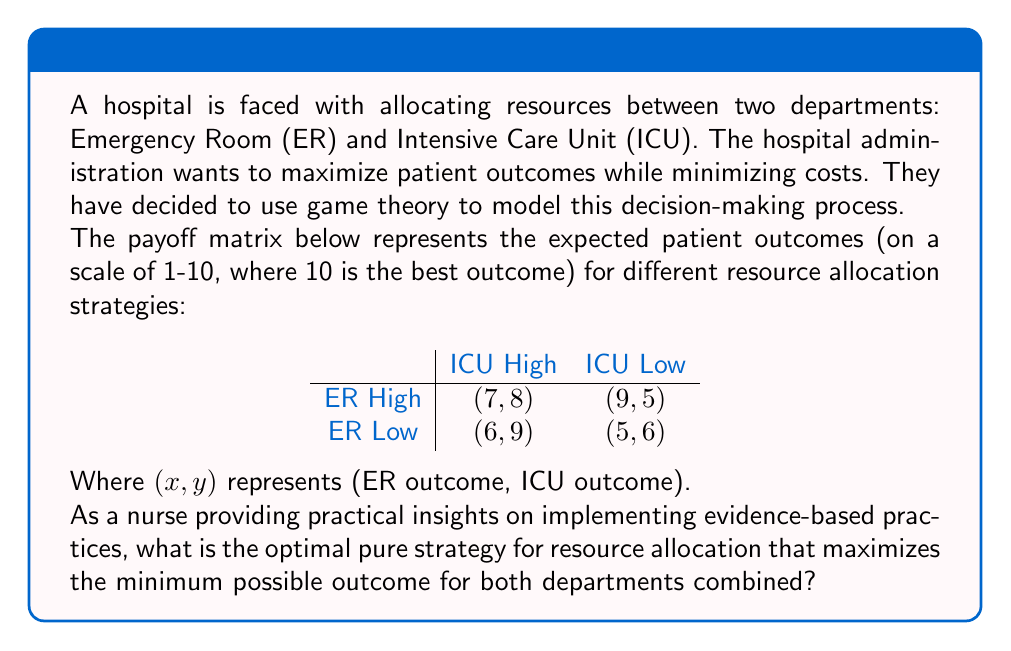Teach me how to tackle this problem. To solve this problem, we need to use the maximin strategy from game theory. This strategy aims to maximize the minimum possible outcome, which aligns with the hospital's goal of ensuring good outcomes for both departments.

Step 1: Identify the minimum combined outcome for each strategy:
1. ER High, ICU High: 7 + 8 = 15
2. ER High, ICU Low: 9 + 5 = 14
3. ER Low, ICU High: 6 + 9 = 15
4. ER Low, ICU Low: 5 + 6 = 11

Step 2: Find the maximum of these minimum outcomes:
The maximum of these minimum outcomes is 15, which occurs in two scenarios: ER High, ICU High and ER Low, ICU High.

Step 3: Consider practical implementation:
As a nurse providing insights on feasibility, we need to consider the practical aspects of implementation. Both strategies that yield the maximum minimum outcome (15) involve high resource allocation to the ICU. However, the ER High, ICU High strategy ensures a more balanced distribution of resources, which is likely to be more feasible and sustainable in a clinical setting.

The ER High, ICU High strategy allows for:
1. Adequate staffing in both departments
2. Balanced equipment and supply distribution
3. Flexibility to handle sudden influxes in either department

While the ER Low, ICU High strategy might lead to longer wait times and potential understaffing in the ER, which could negatively impact patient care and staff morale.

Therefore, from a practical nursing perspective, the optimal pure strategy for resource allocation is ER High, ICU High.
Answer: The optimal pure strategy for resource allocation is ER High, ICU High, which yields a combined minimum outcome of 15 (7 for ER + 8 for ICU) and provides a balanced distribution of resources that is feasible to implement in a clinical setting. 